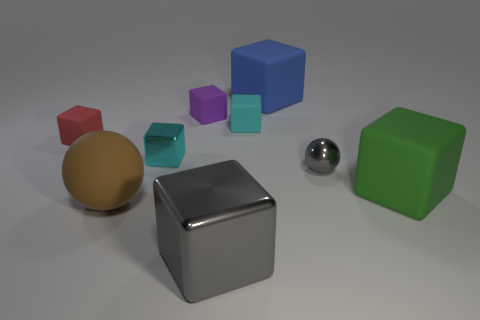Subtract all blue cylinders. How many cyan blocks are left? 2 Subtract all tiny cyan rubber blocks. How many blocks are left? 6 Add 1 yellow things. How many objects exist? 10 Subtract all gray blocks. How many blocks are left? 6 Subtract all spheres. How many objects are left? 7 Subtract all blue blocks. Subtract all purple balls. How many blocks are left? 6 Add 9 small cyan metal blocks. How many small cyan metal blocks exist? 10 Subtract 0 gray cylinders. How many objects are left? 9 Subtract all tiny purple objects. Subtract all tiny red blocks. How many objects are left? 7 Add 8 large gray cubes. How many large gray cubes are left? 9 